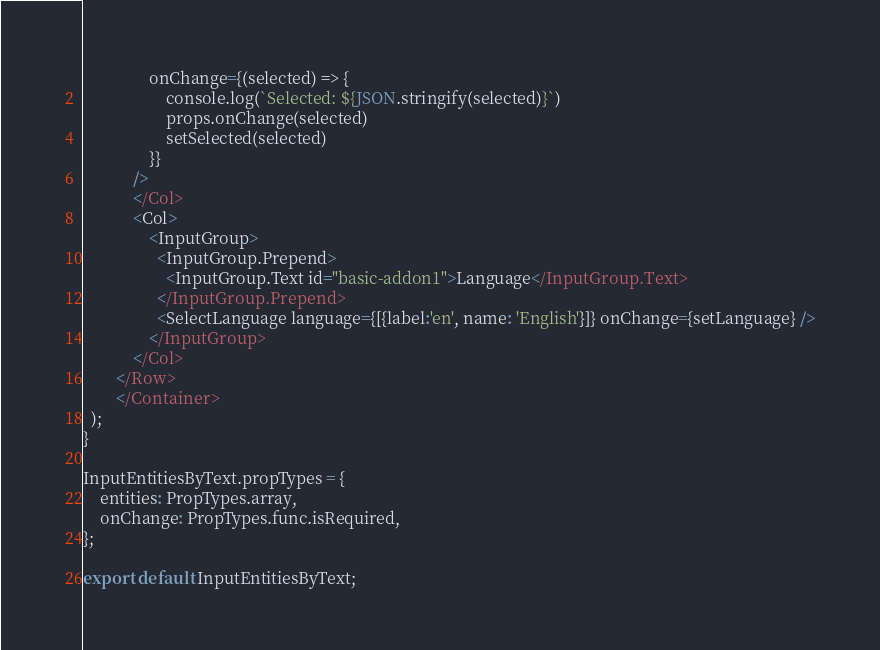Convert code to text. <code><loc_0><loc_0><loc_500><loc_500><_JavaScript_>                onChange={(selected) => {
                    console.log(`Selected: ${JSON.stringify(selected)}`)
                    props.onChange(selected)
                    setSelected(selected)
                }}
            />
            </Col>
            <Col>
                <InputGroup>
                  <InputGroup.Prepend>
                    <InputGroup.Text id="basic-addon1">Language</InputGroup.Text>
                  </InputGroup.Prepend>
                  <SelectLanguage language={[{label:'en', name: 'English'}]} onChange={setLanguage} />
                </InputGroup>
            </Col>
        </Row>
        </Container>
  );
}

InputEntitiesByText.propTypes = {
    entities: PropTypes.array,
    onChange: PropTypes.func.isRequired,
};

export default InputEntitiesByText;
</code> 